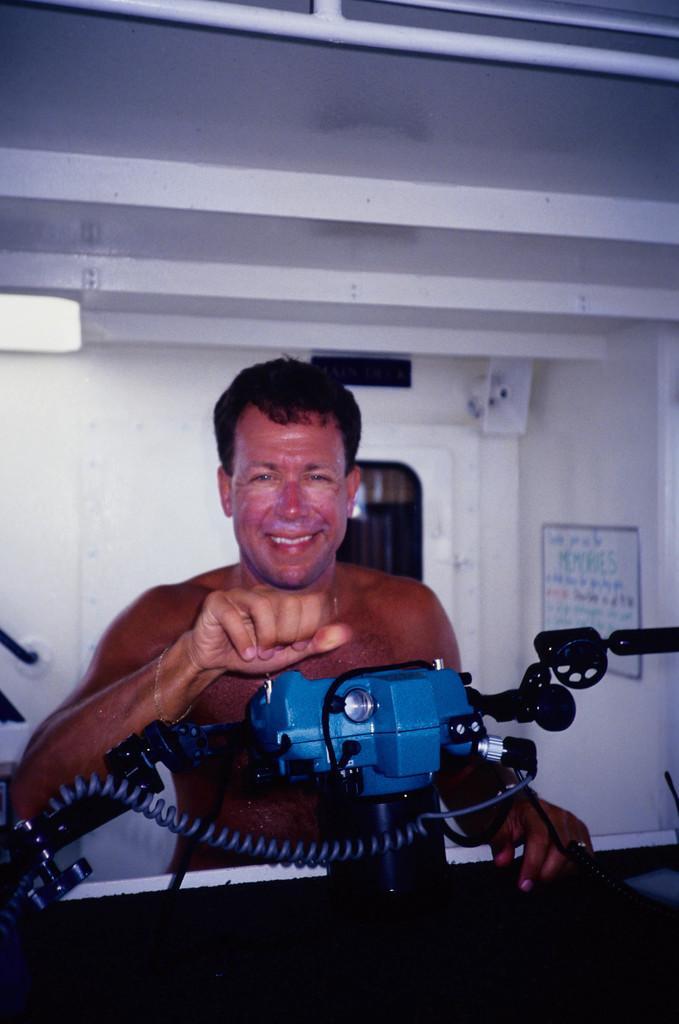Describe this image in one or two sentences. In this picture we can see a person, machine and in the background we can see a wall, poster. 